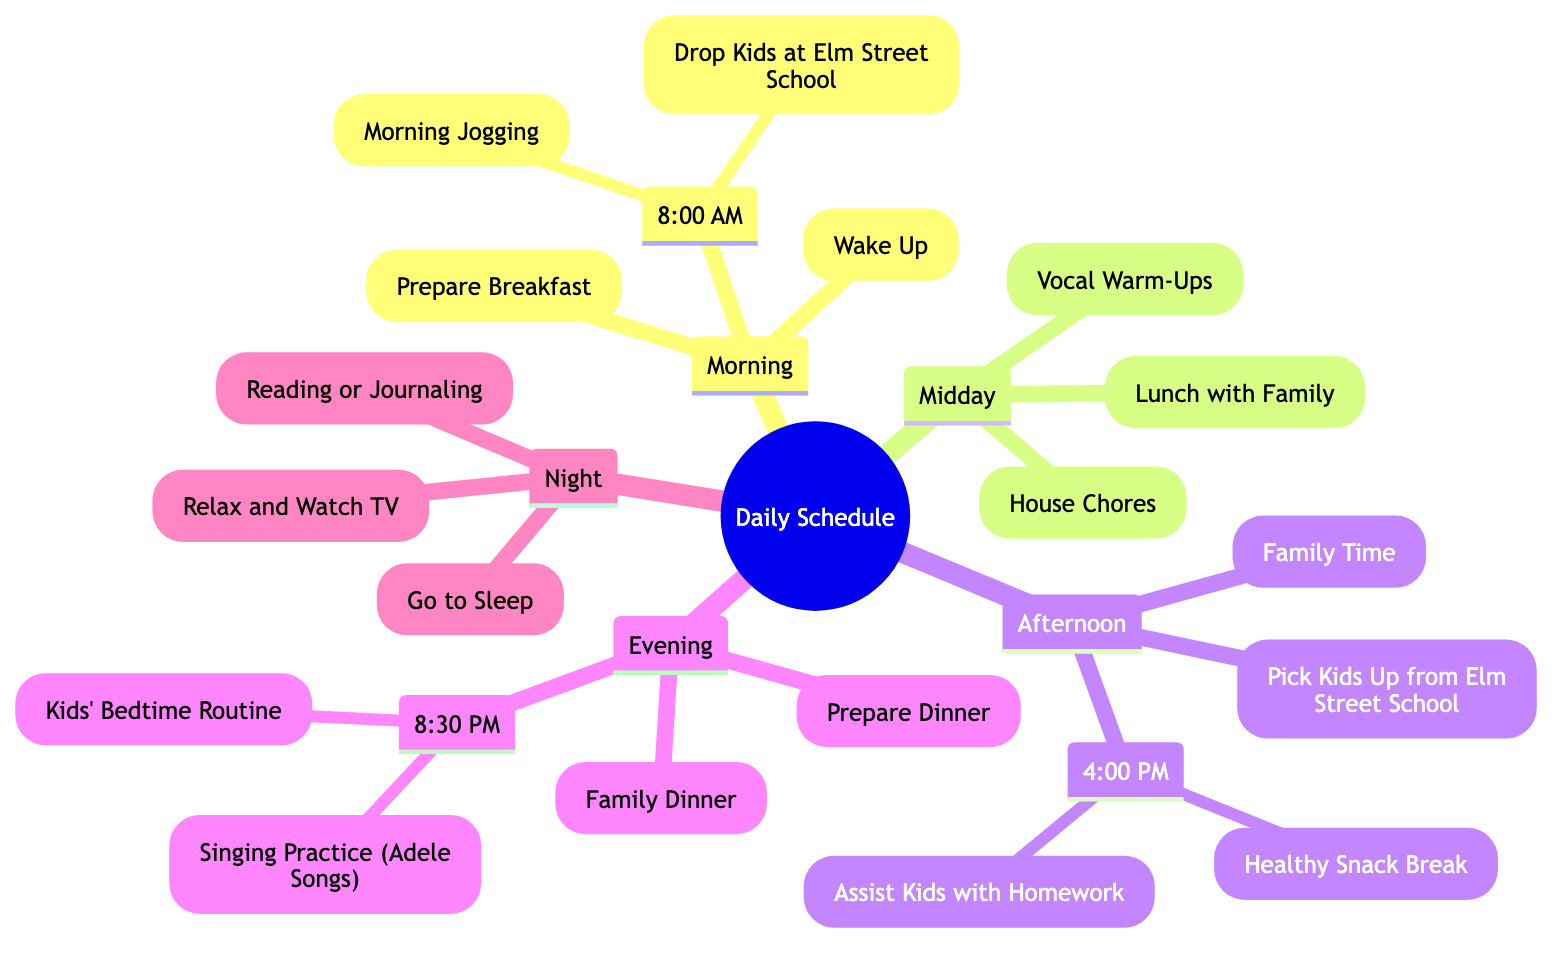What time is "Prepare Breakfast"? The diagram indicates that "Prepare Breakfast" occurs at 7:00 AM within the "Morning" section.
Answer: 7:00 AM What is the first activity in the Evening? The first activity in the Evening section is "Prepare Dinner," which starts at 6:30 PM.
Answer: Prepare Dinner How many main sections are in the daily schedule? The daily schedule is divided into four main sections: Morning, Midday, Afternoon, and Evening. Therefore, there are four sections.
Answer: 4 Which activity occurs right after "Vocal Warm-Ups"? After "Vocal Warm-Ups," which takes place at 2:00 PM, the next activity listed in the diagram is "Pick Kids Up from Elm Street School" at 3:30 PM.
Answer: Pick Kids Up from Elm Street School At what time does the family have dinner? The family has dinner at 7:30 PM according to the Evening section of the diagram.
Answer: 7:30 PM What activities are scheduled in the Afternoon section? In the Afternoon section, the activities are "Pick Kids Up from Elm Street School," "Assist Kids with Homework," and "Healthy Snack Break." I need to identify these three activities in sequence.
Answer: Pick Kids Up from Elm Street School, Assist Kids with Homework, Healthy Snack Break What activity is scheduled after "Kids' Bedtime Routine"? The last activity listed after "Kids' Bedtime Routine," which takes place at 8:30 PM, is "Relax and Watch TV" at 9:30 PM.
Answer: Relax and Watch TV Which activities take place during the Midday section? The Midday section includes "Lunch with Family," "House Chores," and "Vocal Warm-Ups." These three activities define the Midday routine as per the diagram.
Answer: Lunch with Family, House Chores, Vocal Warm-Ups What is the total number of activities in the diagram? After counting all activities in each section, the total becomes ten: four in the Morning, three in the Midday, three in the Afternoon, and three in the Evening, totaling ten activities.
Answer: 10 